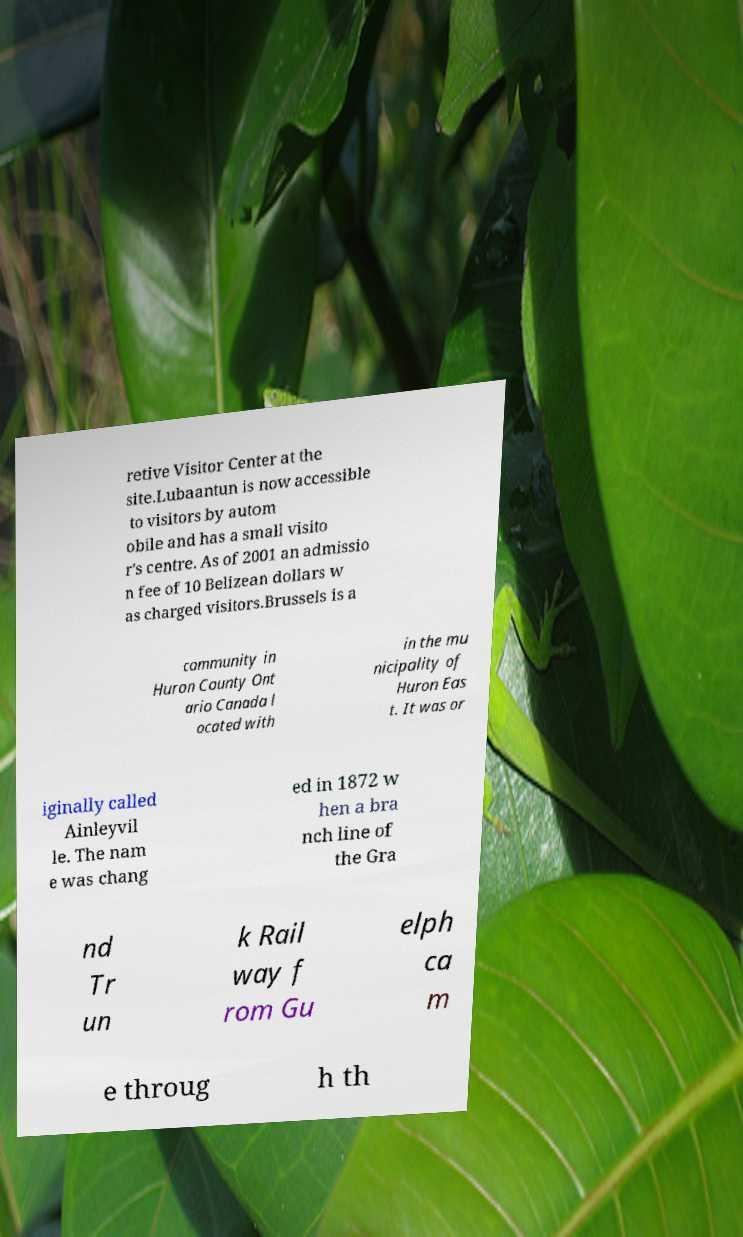There's text embedded in this image that I need extracted. Can you transcribe it verbatim? retive Visitor Center at the site.Lubaantun is now accessible to visitors by autom obile and has a small visito r's centre. As of 2001 an admissio n fee of 10 Belizean dollars w as charged visitors.Brussels is a community in Huron County Ont ario Canada l ocated with in the mu nicipality of Huron Eas t. It was or iginally called Ainleyvil le. The nam e was chang ed in 1872 w hen a bra nch line of the Gra nd Tr un k Rail way f rom Gu elph ca m e throug h th 